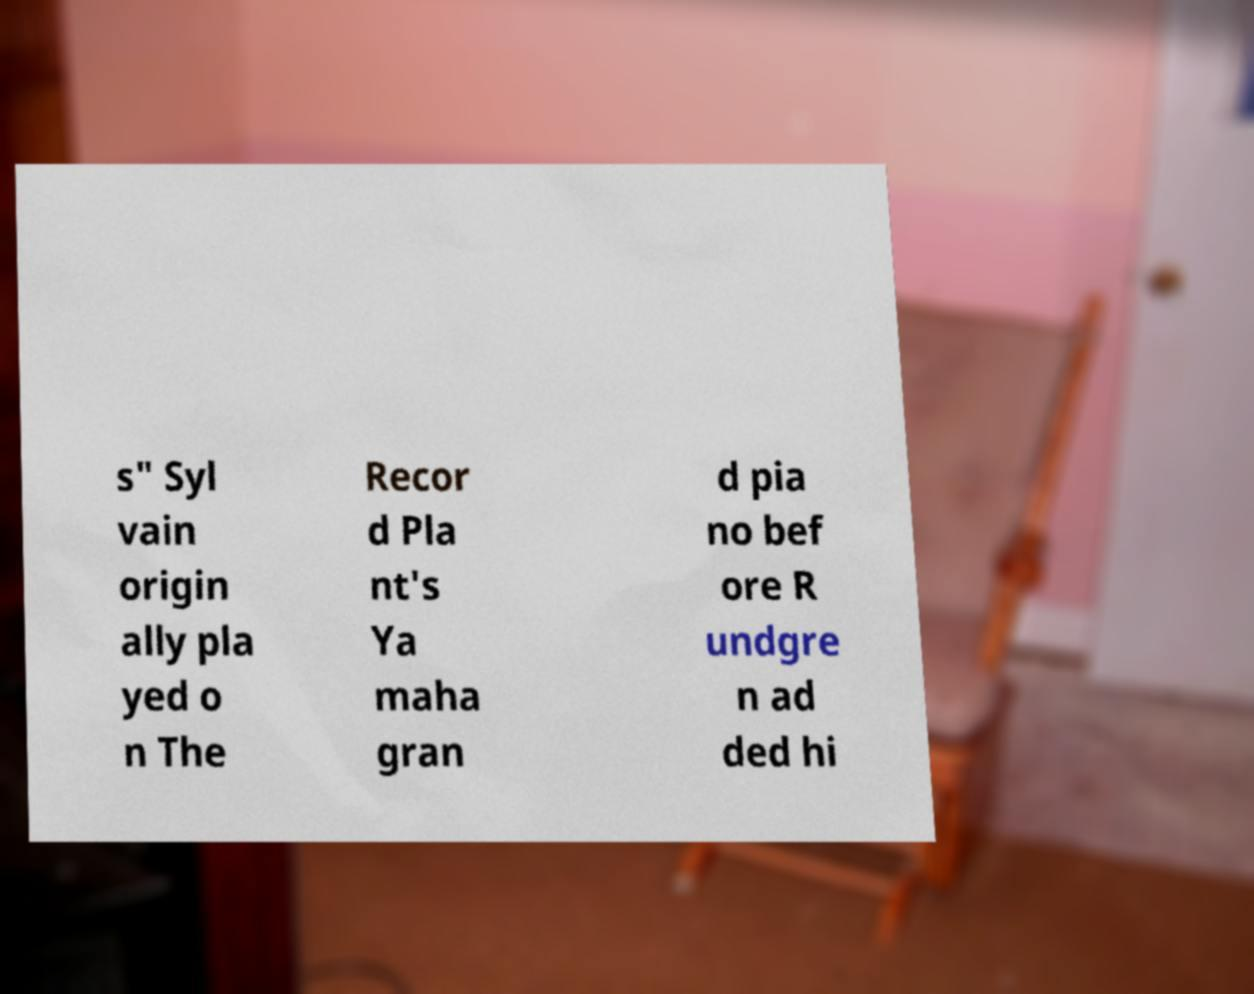Could you assist in decoding the text presented in this image and type it out clearly? s" Syl vain origin ally pla yed o n The Recor d Pla nt's Ya maha gran d pia no bef ore R undgre n ad ded hi 